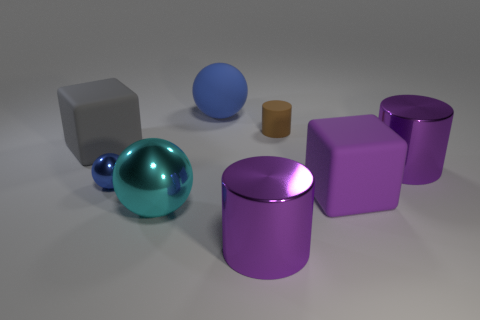Are there any objects that could indicate the scale of the scene? Without familiar objects to compare against, it's difficult to determine the absolute scale of the scene. Could the texture of the ground provide clues to the scale? The texture of the ground is quite smooth, without any distinct patterns or markings, so it doesn't offer much insight into the scale of the objects. 